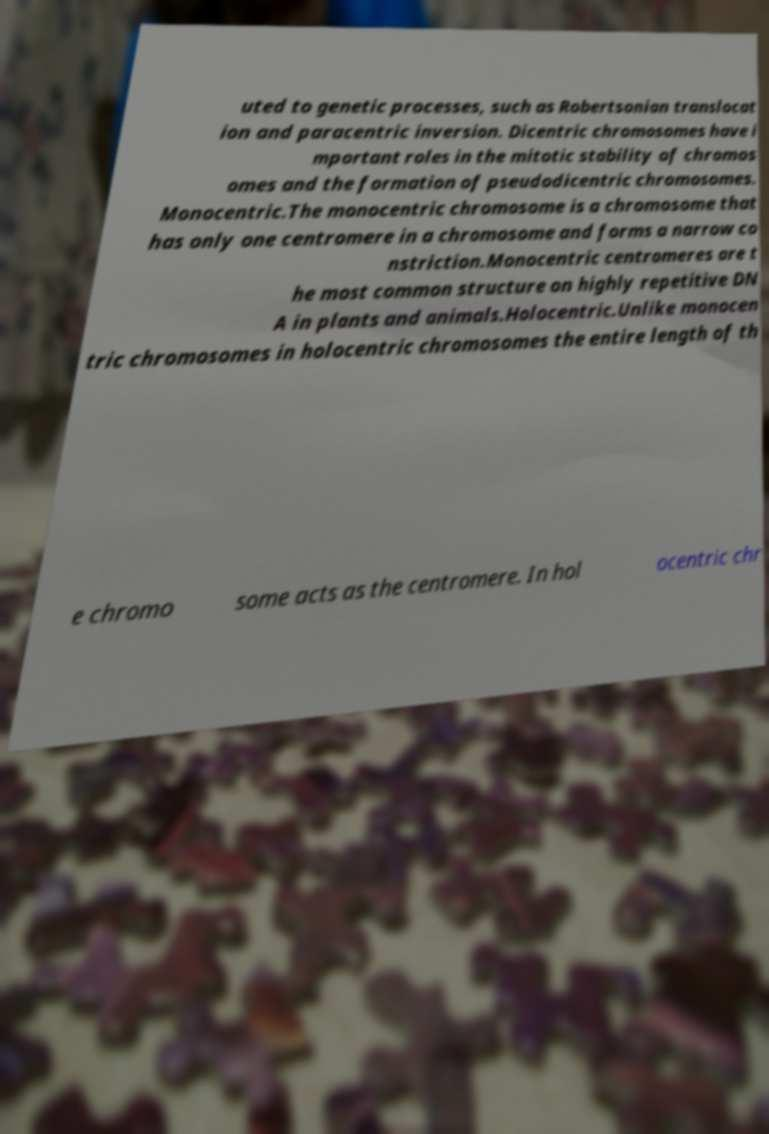Can you accurately transcribe the text from the provided image for me? uted to genetic processes, such as Robertsonian translocat ion and paracentric inversion. Dicentric chromosomes have i mportant roles in the mitotic stability of chromos omes and the formation of pseudodicentric chromosomes. Monocentric.The monocentric chromosome is a chromosome that has only one centromere in a chromosome and forms a narrow co nstriction.Monocentric centromeres are t he most common structure on highly repetitive DN A in plants and animals.Holocentric.Unlike monocen tric chromosomes in holocentric chromosomes the entire length of th e chromo some acts as the centromere. In hol ocentric chr 